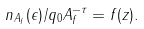<formula> <loc_0><loc_0><loc_500><loc_500>n _ { A _ { f } } ( \epsilon ) / q _ { 0 } A _ { f } ^ { - \tau } = f ( z ) .</formula> 